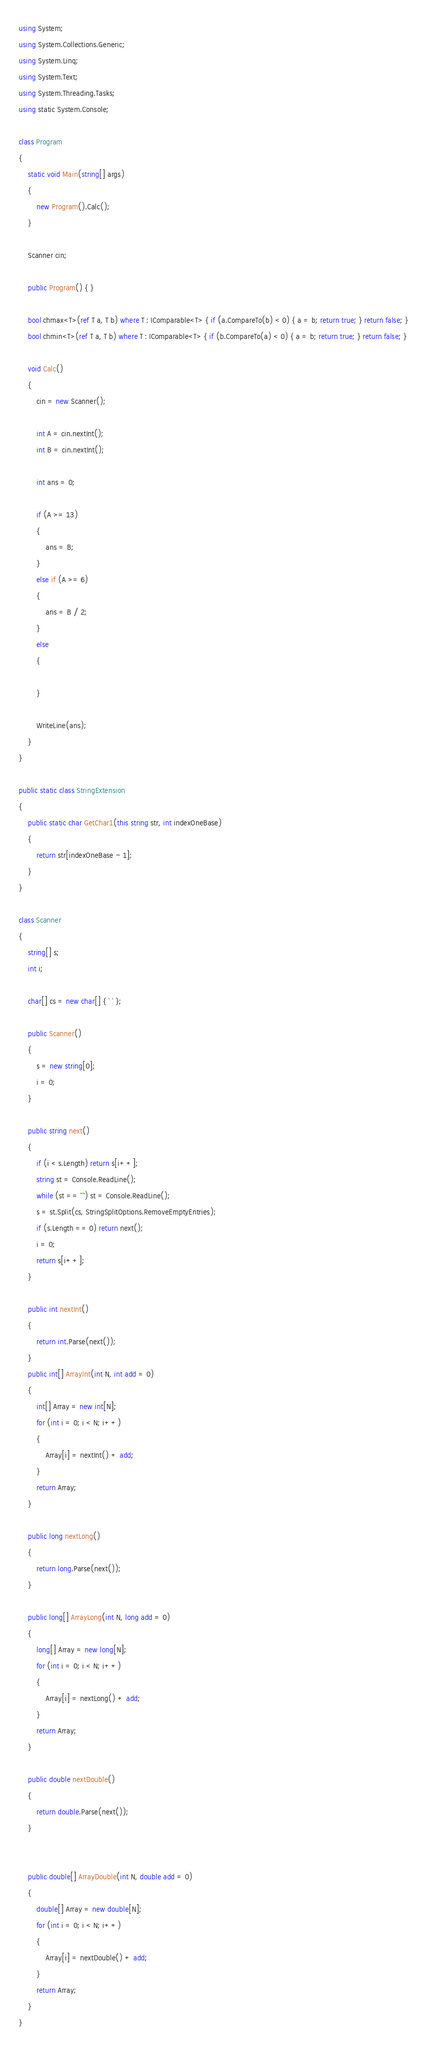<code> <loc_0><loc_0><loc_500><loc_500><_C#_>using System;
using System.Collections.Generic;
using System.Linq;
using System.Text;
using System.Threading.Tasks;
using static System.Console;

class Program
{
    static void Main(string[] args)
    {
        new Program().Calc();
    }

    Scanner cin;

    public Program() { }

    bool chmax<T>(ref T a, T b) where T : IComparable<T> { if (a.CompareTo(b) < 0) { a = b; return true; } return false; }
    bool chmin<T>(ref T a, T b) where T : IComparable<T> { if (b.CompareTo(a) < 0) { a = b; return true; } return false; }

    void Calc()
    {
        cin = new Scanner();

        int A = cin.nextInt();
        int B = cin.nextInt();

        int ans = 0;

        if (A >= 13)
        {
            ans = B;
        }
        else if (A >= 6)
        {
            ans = B / 2;
        }
        else
        {

        }

        WriteLine(ans);
    }
}

public static class StringExtension
{
    public static char GetChar1(this string str, int indexOneBase)
    {
        return str[indexOneBase - 1];
    }
}

class Scanner
{
    string[] s;
    int i;

    char[] cs = new char[] { ' ' };

    public Scanner()
    {
        s = new string[0];
        i = 0;
    }

    public string next()
    {
        if (i < s.Length) return s[i++];
        string st = Console.ReadLine();
        while (st == "") st = Console.ReadLine();
        s = st.Split(cs, StringSplitOptions.RemoveEmptyEntries);
        if (s.Length == 0) return next();
        i = 0;
        return s[i++];
    }

    public int nextInt()
    {
        return int.Parse(next());
    }
    public int[] ArrayInt(int N, int add = 0)
    {
        int[] Array = new int[N];
        for (int i = 0; i < N; i++)
        {
            Array[i] = nextInt() + add;
        }
        return Array;
    }

    public long nextLong()
    {
        return long.Parse(next());
    }

    public long[] ArrayLong(int N, long add = 0)
    {
        long[] Array = new long[N];
        for (int i = 0; i < N; i++)
        {
            Array[i] = nextLong() + add;
        }
        return Array;
    }

    public double nextDouble()
    {
        return double.Parse(next());
    }


    public double[] ArrayDouble(int N, double add = 0)
    {
        double[] Array = new double[N];
        for (int i = 0; i < N; i++)
        {
            Array[i] = nextDouble() + add;
        }
        return Array;
    }
}
</code> 